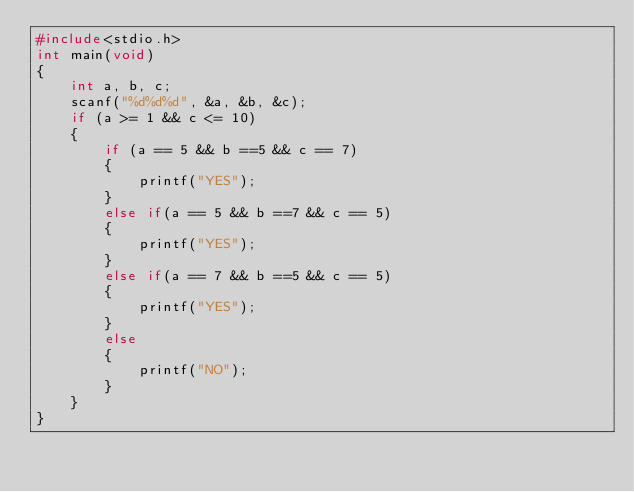<code> <loc_0><loc_0><loc_500><loc_500><_C_>#include<stdio.h>
int main(void)
{
	int a, b, c;
	scanf("%d%d%d", &a, &b, &c);
	if (a >= 1 && c <= 10)
	{
		if (a == 5 && b ==5 && c == 7)
		{
			printf("YES");
		}
		else if(a == 5 && b ==7 && c == 5)
		{
			printf("YES");
		}
		else if(a == 7 && b ==5 && c == 5)
		{
			printf("YES");
		}
		else
		{
			printf("NO");
		}
	}
}</code> 